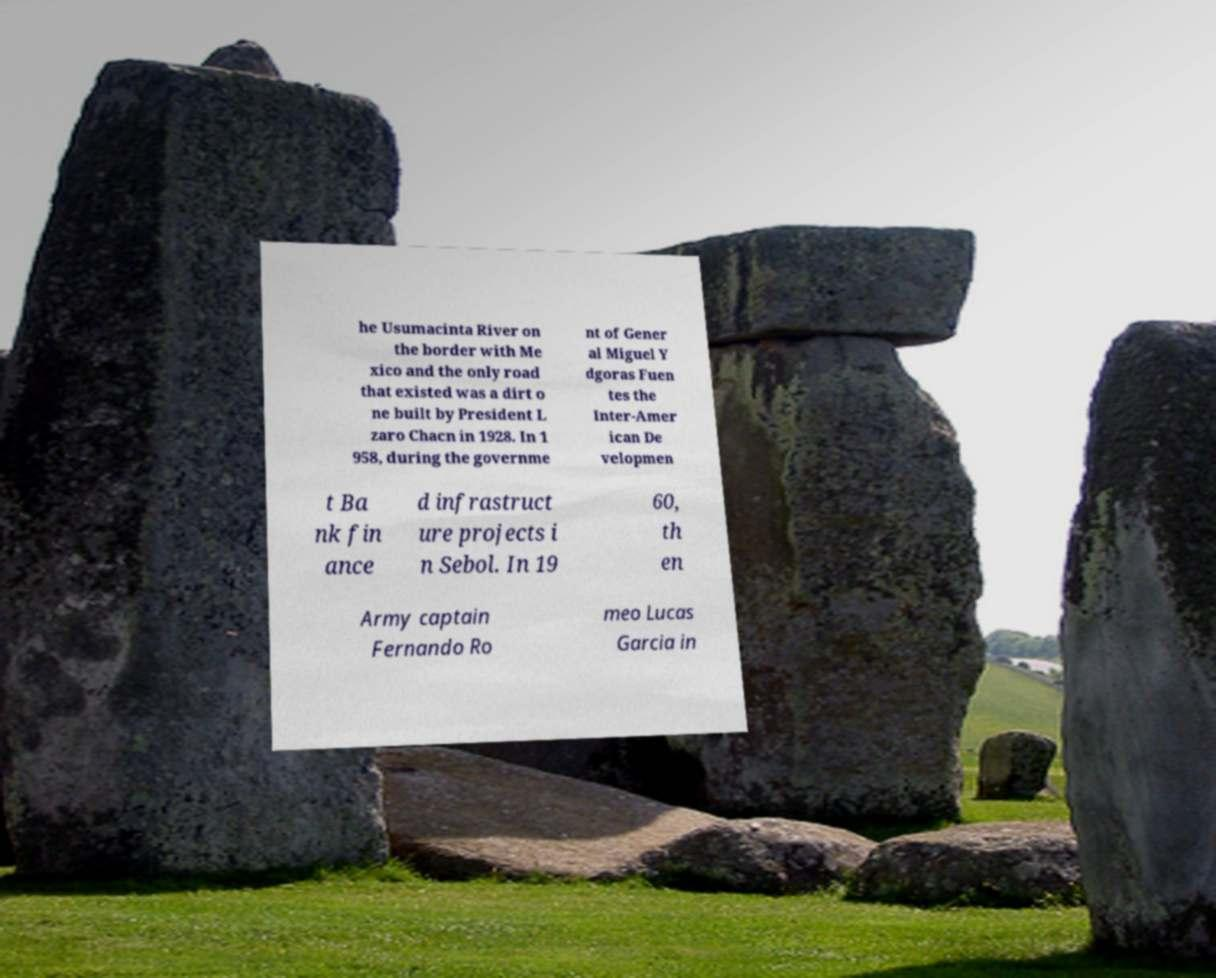Can you read and provide the text displayed in the image?This photo seems to have some interesting text. Can you extract and type it out for me? he Usumacinta River on the border with Me xico and the only road that existed was a dirt o ne built by President L zaro Chacn in 1928. In 1 958, during the governme nt of Gener al Miguel Y dgoras Fuen tes the Inter-Amer ican De velopmen t Ba nk fin ance d infrastruct ure projects i n Sebol. In 19 60, th en Army captain Fernando Ro meo Lucas Garcia in 